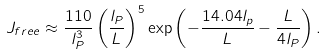Convert formula to latex. <formula><loc_0><loc_0><loc_500><loc_500>J _ { f r e e } \approx \frac { 1 1 0 } { l _ { P } ^ { 3 } } \left ( \frac { l _ { P } } { L } \right ) ^ { 5 } \exp \left ( - \frac { 1 4 . 0 4 l _ { p } } { L } - \frac { L } { 4 l _ { P } } \right ) .</formula> 